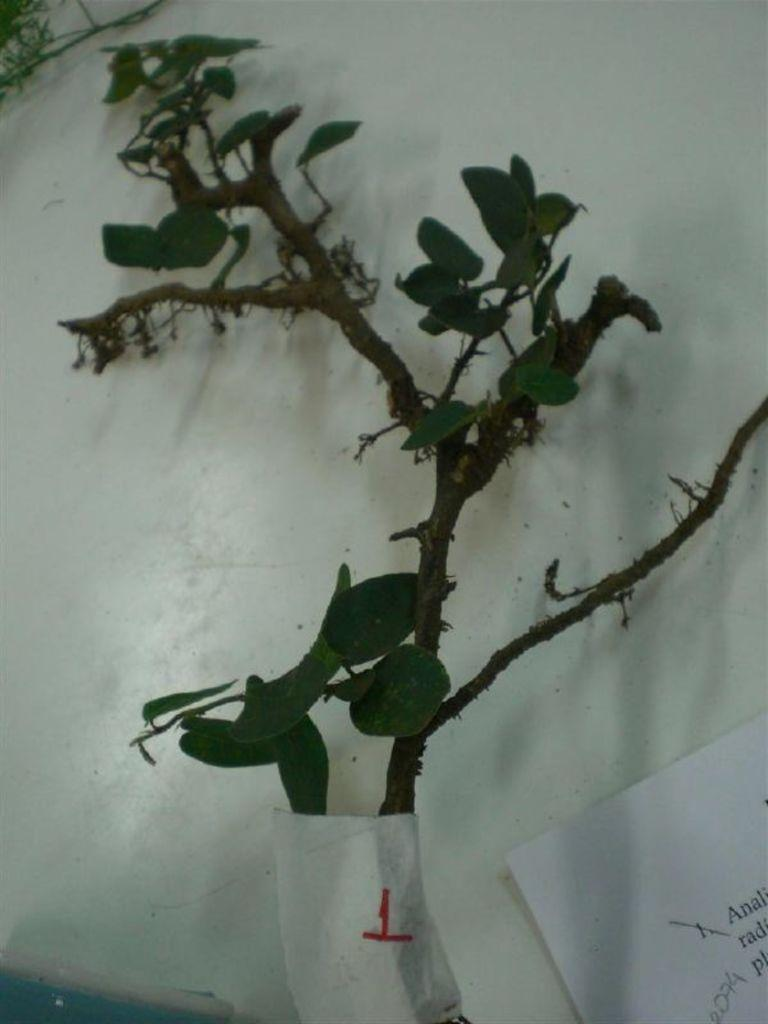What type of plant can be seen in the image? There is a tree in the image. What is the paper with text used for in the image? The purpose of the paper with text is not specified in the image. What can be seen in the background of the image? There is a wall in the background of the image. What type of lettuce is being used to decorate the cake in the image? There is no cake or lettuce present in the image. How is the butter being used in the image? There is no butter present in the image. 